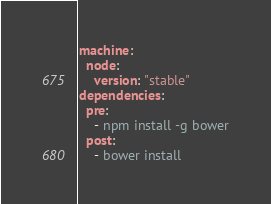Convert code to text. <code><loc_0><loc_0><loc_500><loc_500><_YAML_>machine:
  node:
    version: "stable"
dependencies:
  pre:
    - npm install -g bower
  post:
    - bower install
</code> 